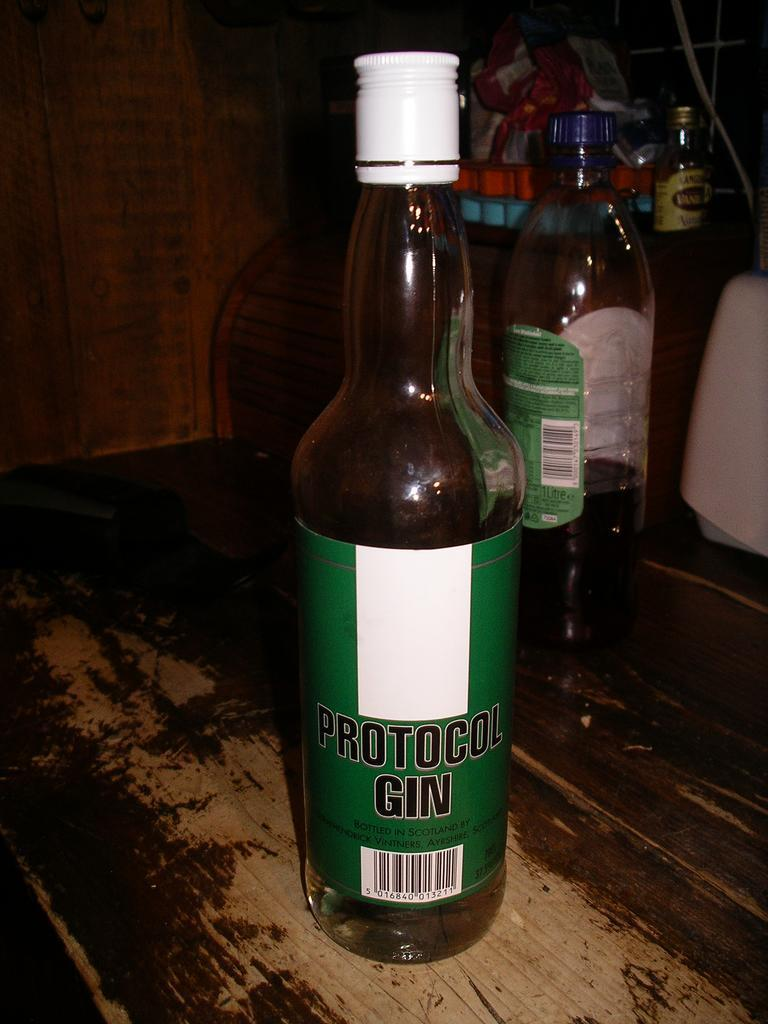<image>
Relay a brief, clear account of the picture shown. A bottle of Protocol Gin on a wooden table. 